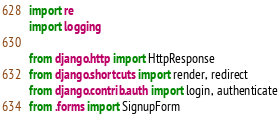<code> <loc_0><loc_0><loc_500><loc_500><_Python_>import re
import logging

from django.http import HttpResponse
from django.shortcuts import render, redirect
from django.contrib.auth import login, authenticate
from .forms import SignupForm</code> 